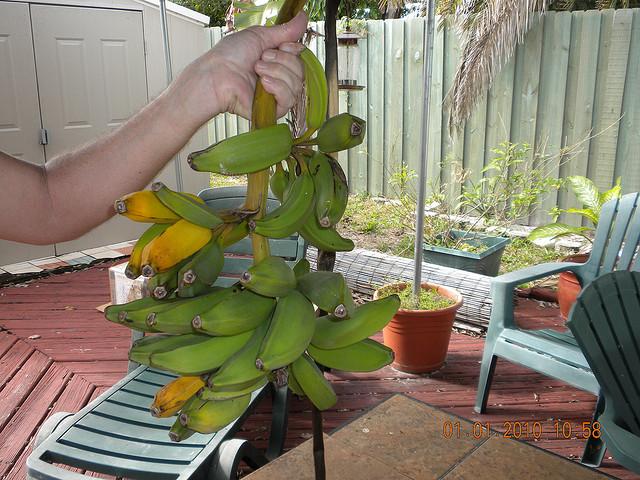Are all the bananas green?
Answer briefly. No. Are the doors closed?
Write a very short answer. Yes. Are all the bananas ripe?
Concise answer only. No. 